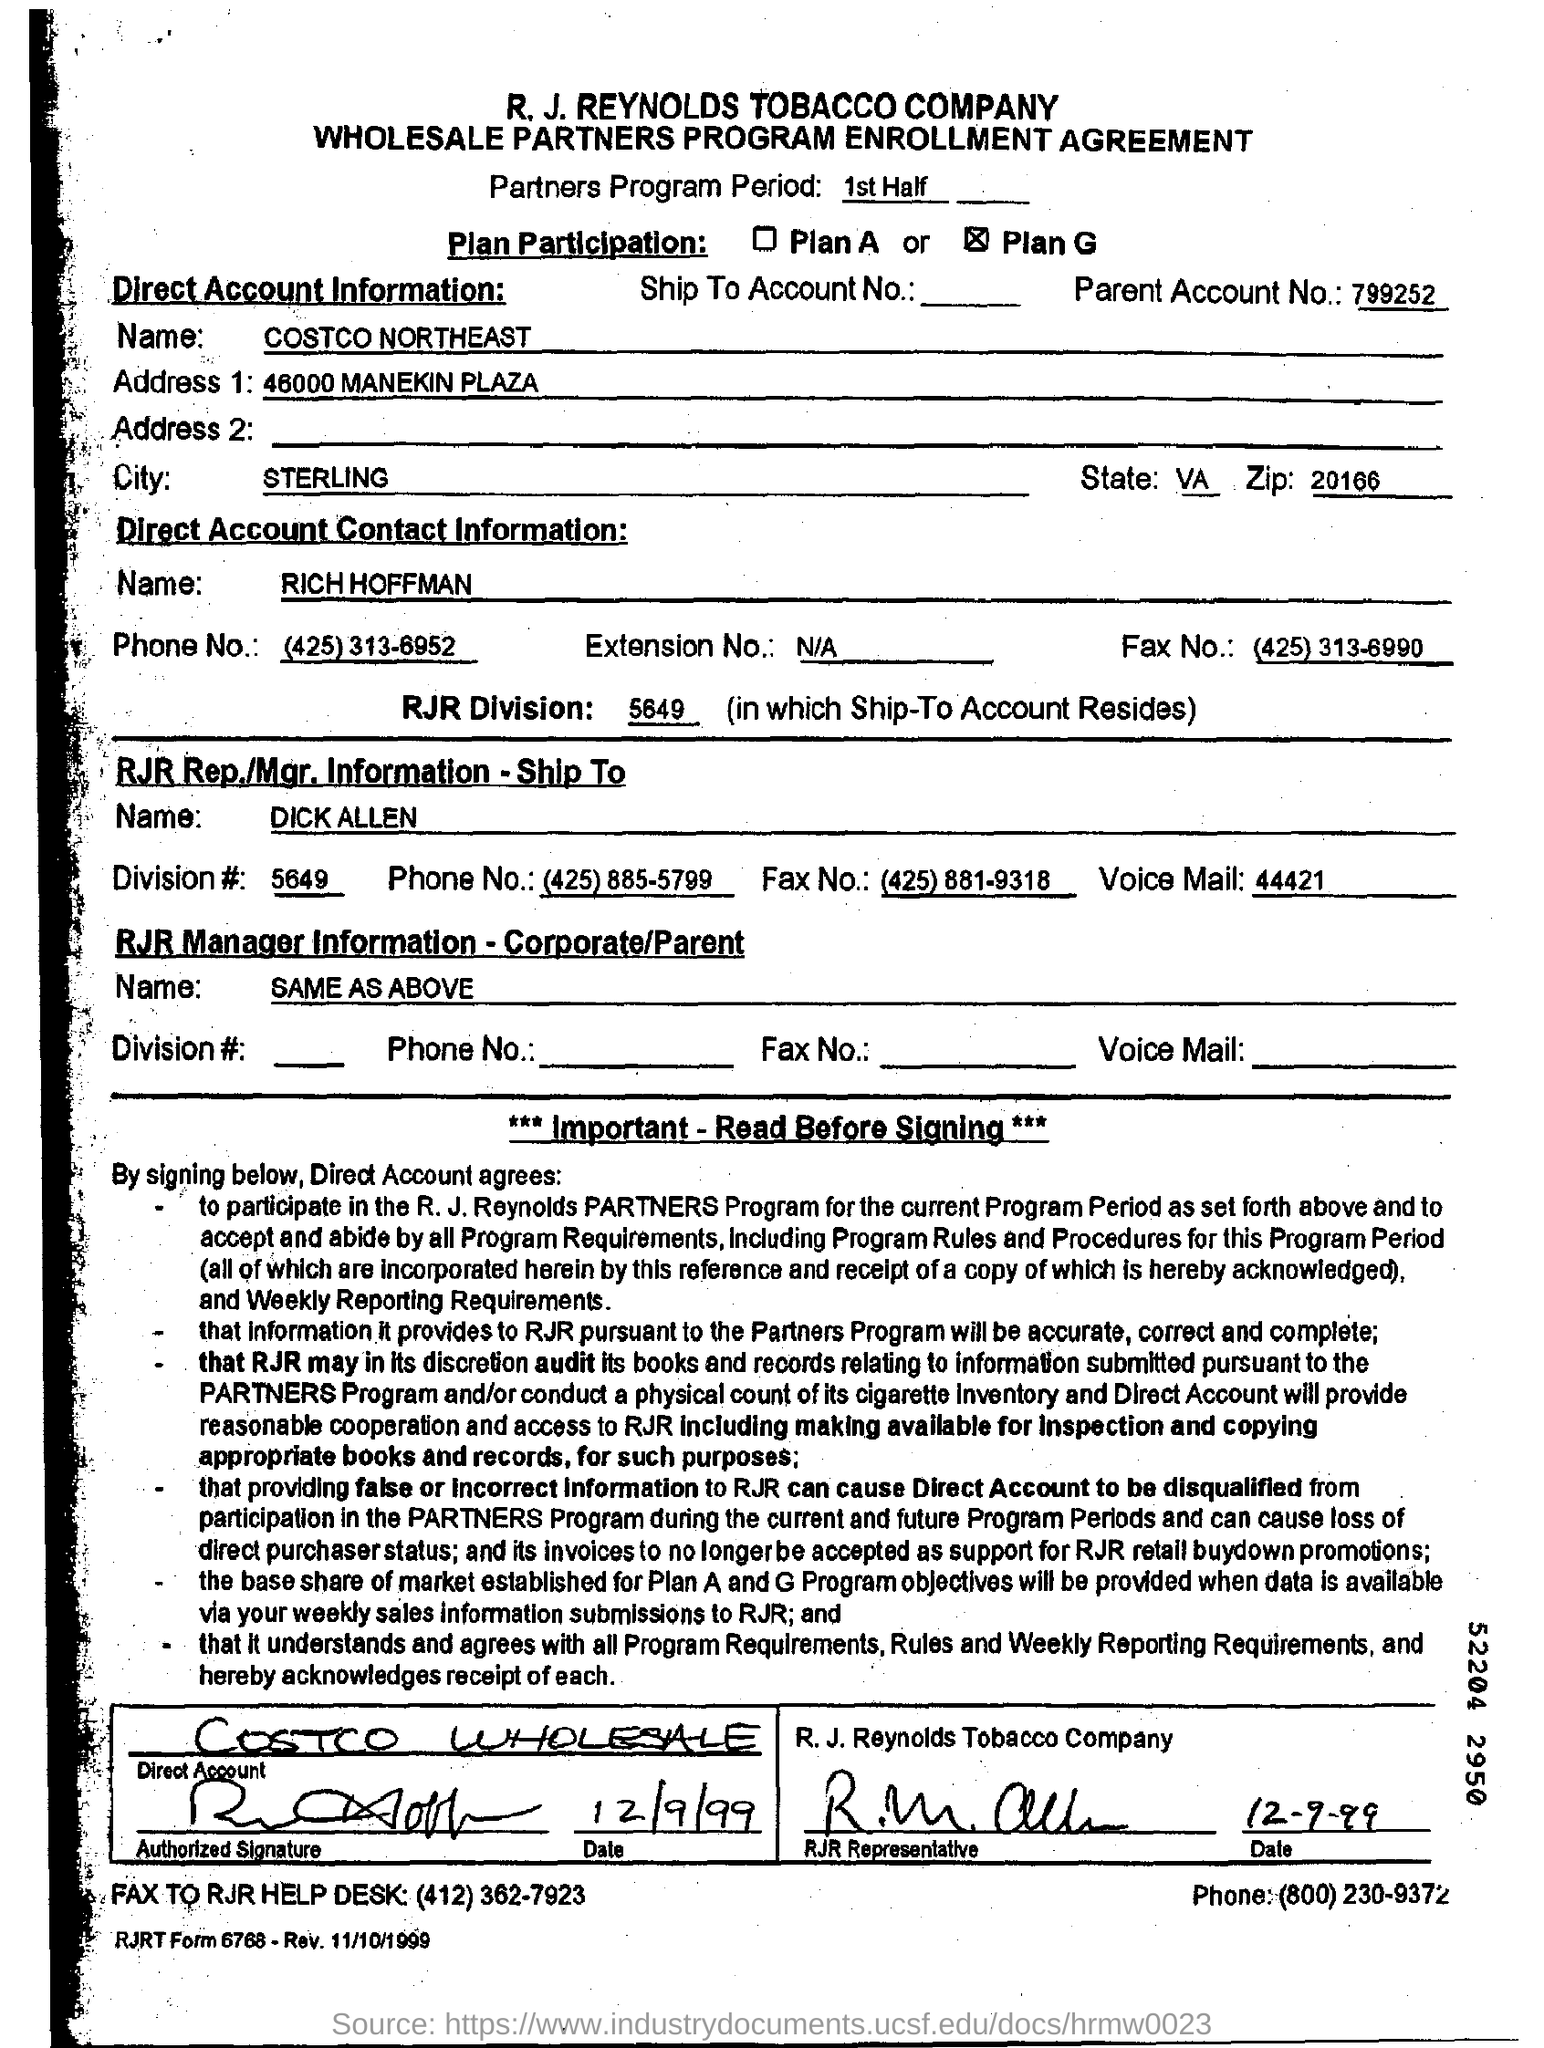Give some essential details in this illustration. The name of RJR Rep is Dick Allen. The second line of the page mentions a document as "What sort of agreement is this? Wholesale Partners Program Enrollment Agreement. According to direct account information, the name of the city is Sterling. The name of the person as per the direct account contact information is RICH HOFFMAN. According to the direct account information, the name of the company is COSTCO NORTHEAST. 